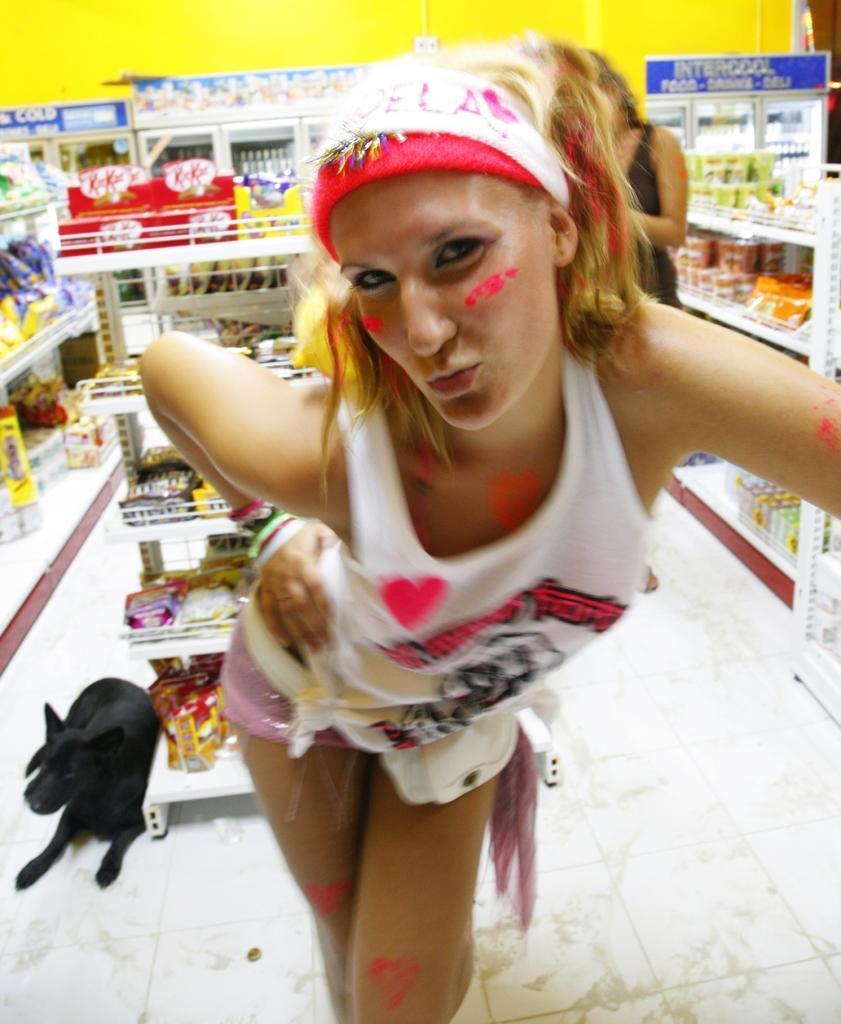In one or two sentences, can you explain what this image depicts? In the center of the image we can see a woman. In the background we can see the store with the racks of packets, cups and also some other objects. We can see the dog and also the floor. In the background we can see the wall and also the board. 